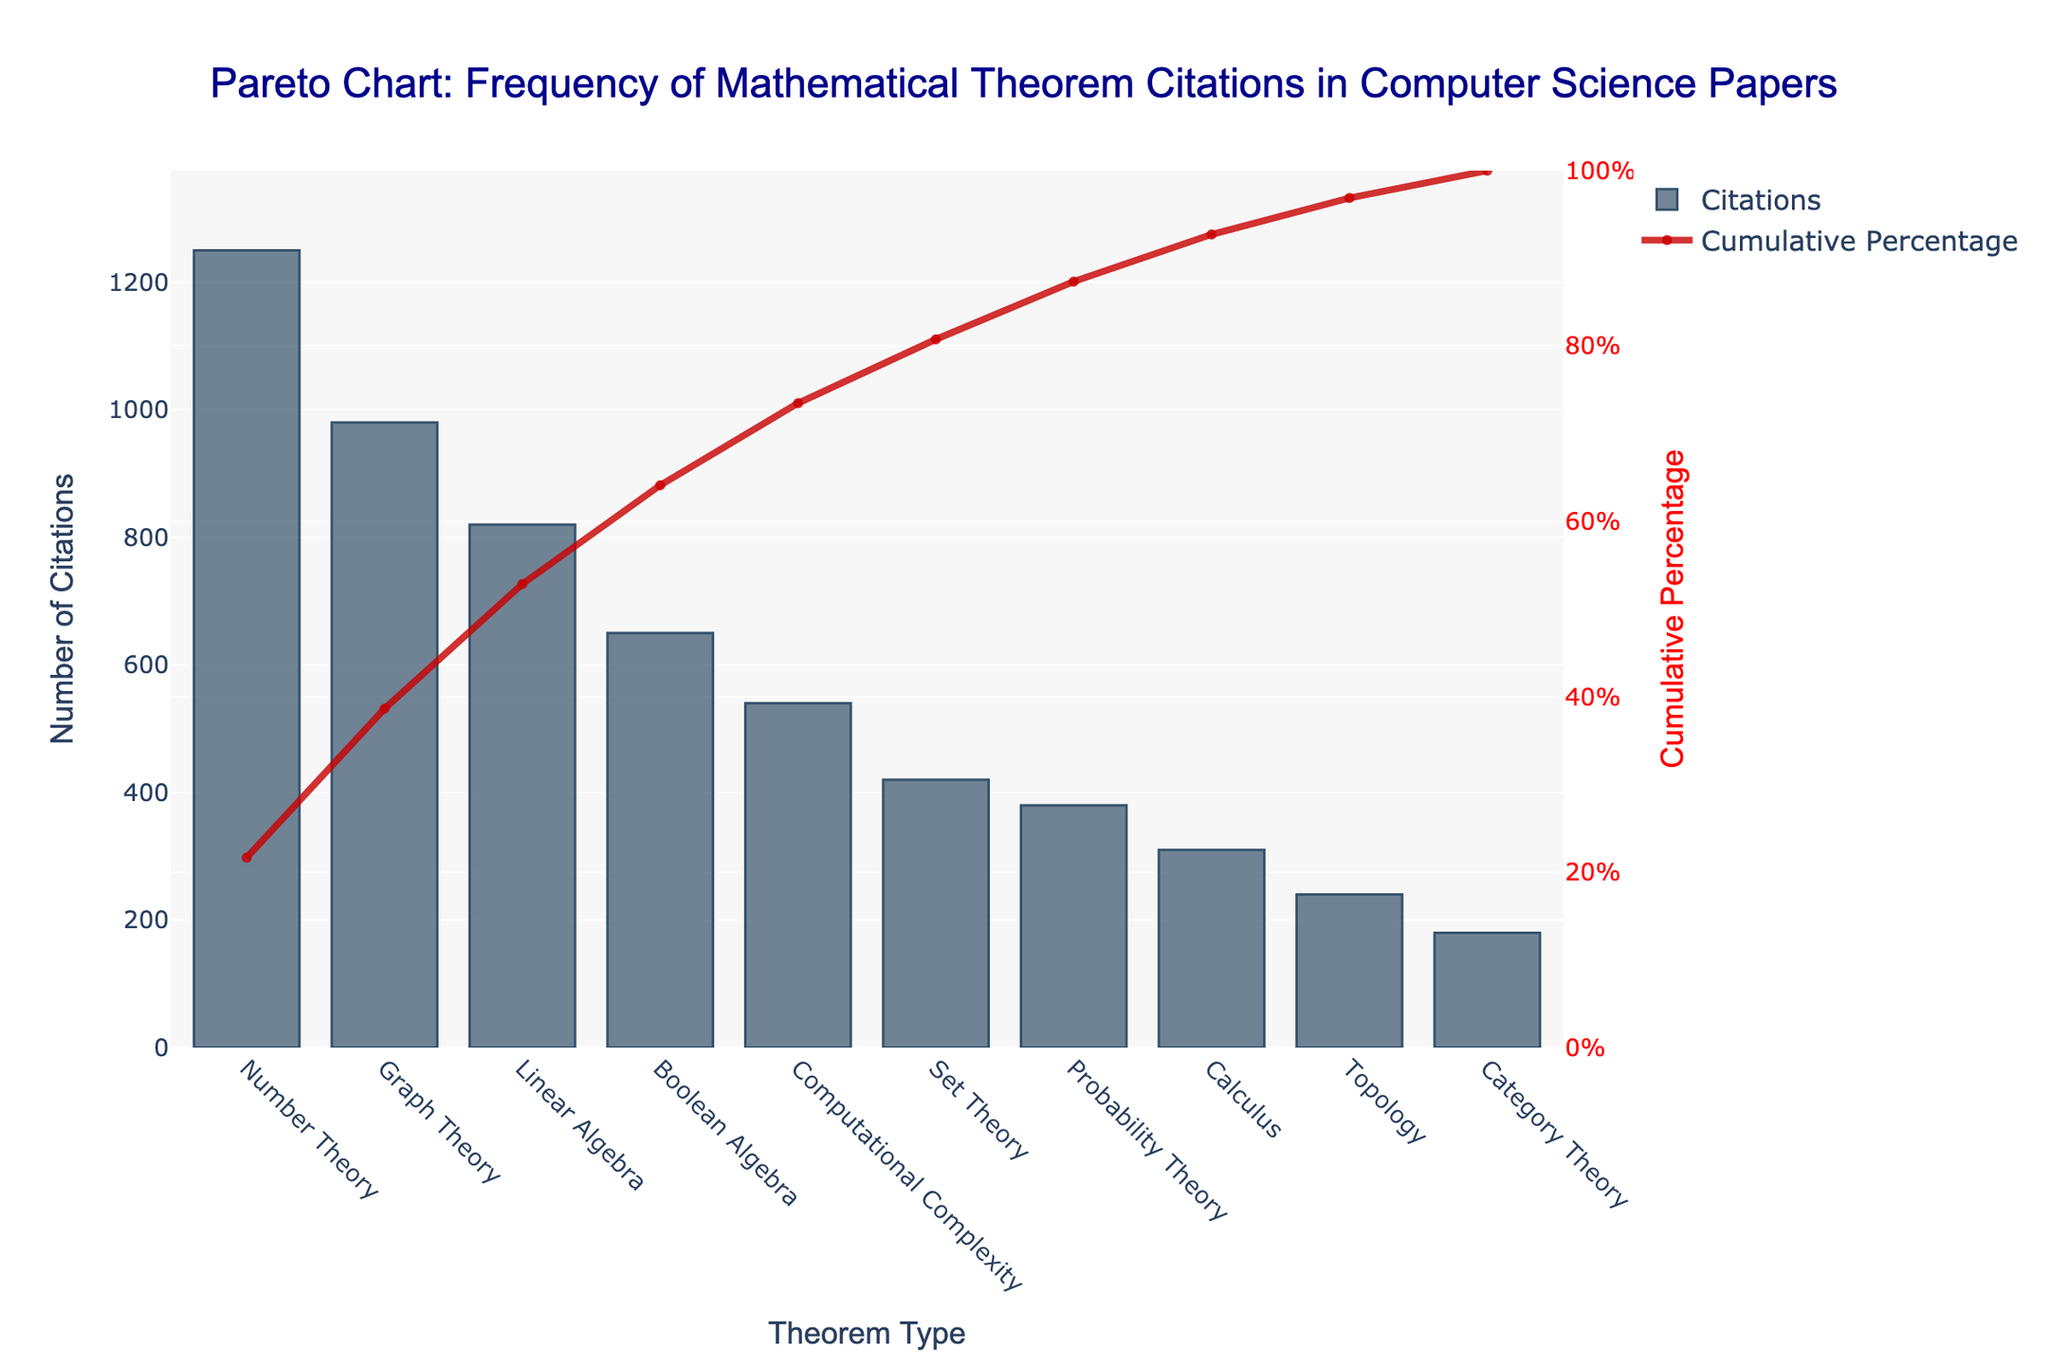What's the title of the chart? The title is displayed at the top of the chart.
Answer: Pareto Chart: Frequency of Mathematical Theorem Citations in Computer Science Papers What is the theorem type with the highest number of citations? Look at the highest bar in the chart, which corresponds to the theorem type with the most citations.
Answer: Number Theory Which theorem type has the lowest number of citations? Look at the shortest bar in the chart, which corresponds to the theorem type with the fewest citations.
Answer: Category Theory What cumulative percentage does Graph Theory reach? Identify the data point for Graph Theory on the line plot and read the corresponding cumulative percentage value on the right y-axis.
Answer: Approximately 61% What is the combined number of citations for Set Theory, Probability Theory, Calculus, Topology, and Category Theory? Sum the number of citations for these theorem types: Set Theory (420), Probability Theory (380), Calculus (310), Topology (240), and Category Theory (180). 420 + 380 + 310 + 240 + 180 = 1530
Answer: 1530 How does Boolean Algebra compare to Computational Complexity in terms of citations? Find the bars for both Boolean Algebra and Computational Complexity and compare their heights.
Answer: Boolean Algebra has more citations than Computational Complexity At what cumulative percentage does Linear Algebra reach? Identify the data point for Linear Algebra on the line plot and read the corresponding cumulative percentage value on the right y-axis.
Answer: Approximately 80% What is the total number of citations represented in the chart? This can be calculated by summing up the citations for all theorem types: 1250 + 980 + 820 + 650 + 540 + 420 + 380 + 310 + 240 + 180 = 5770
Answer: 5770 Which theorem types contribute to the top 50% of cumulative citations? Identify the theorem types where the cumulative percentage reaches 50%: Number Theory, Graph Theory, Linear Algebra.
Answer: Number Theory, Graph Theory, Linear Algebra What’s the difference in the number of citations between Number Theory and Calculus? Subtract the number of citations for Calculus from that for Number Theory: 1250 - 310 = 940
Answer: 940 